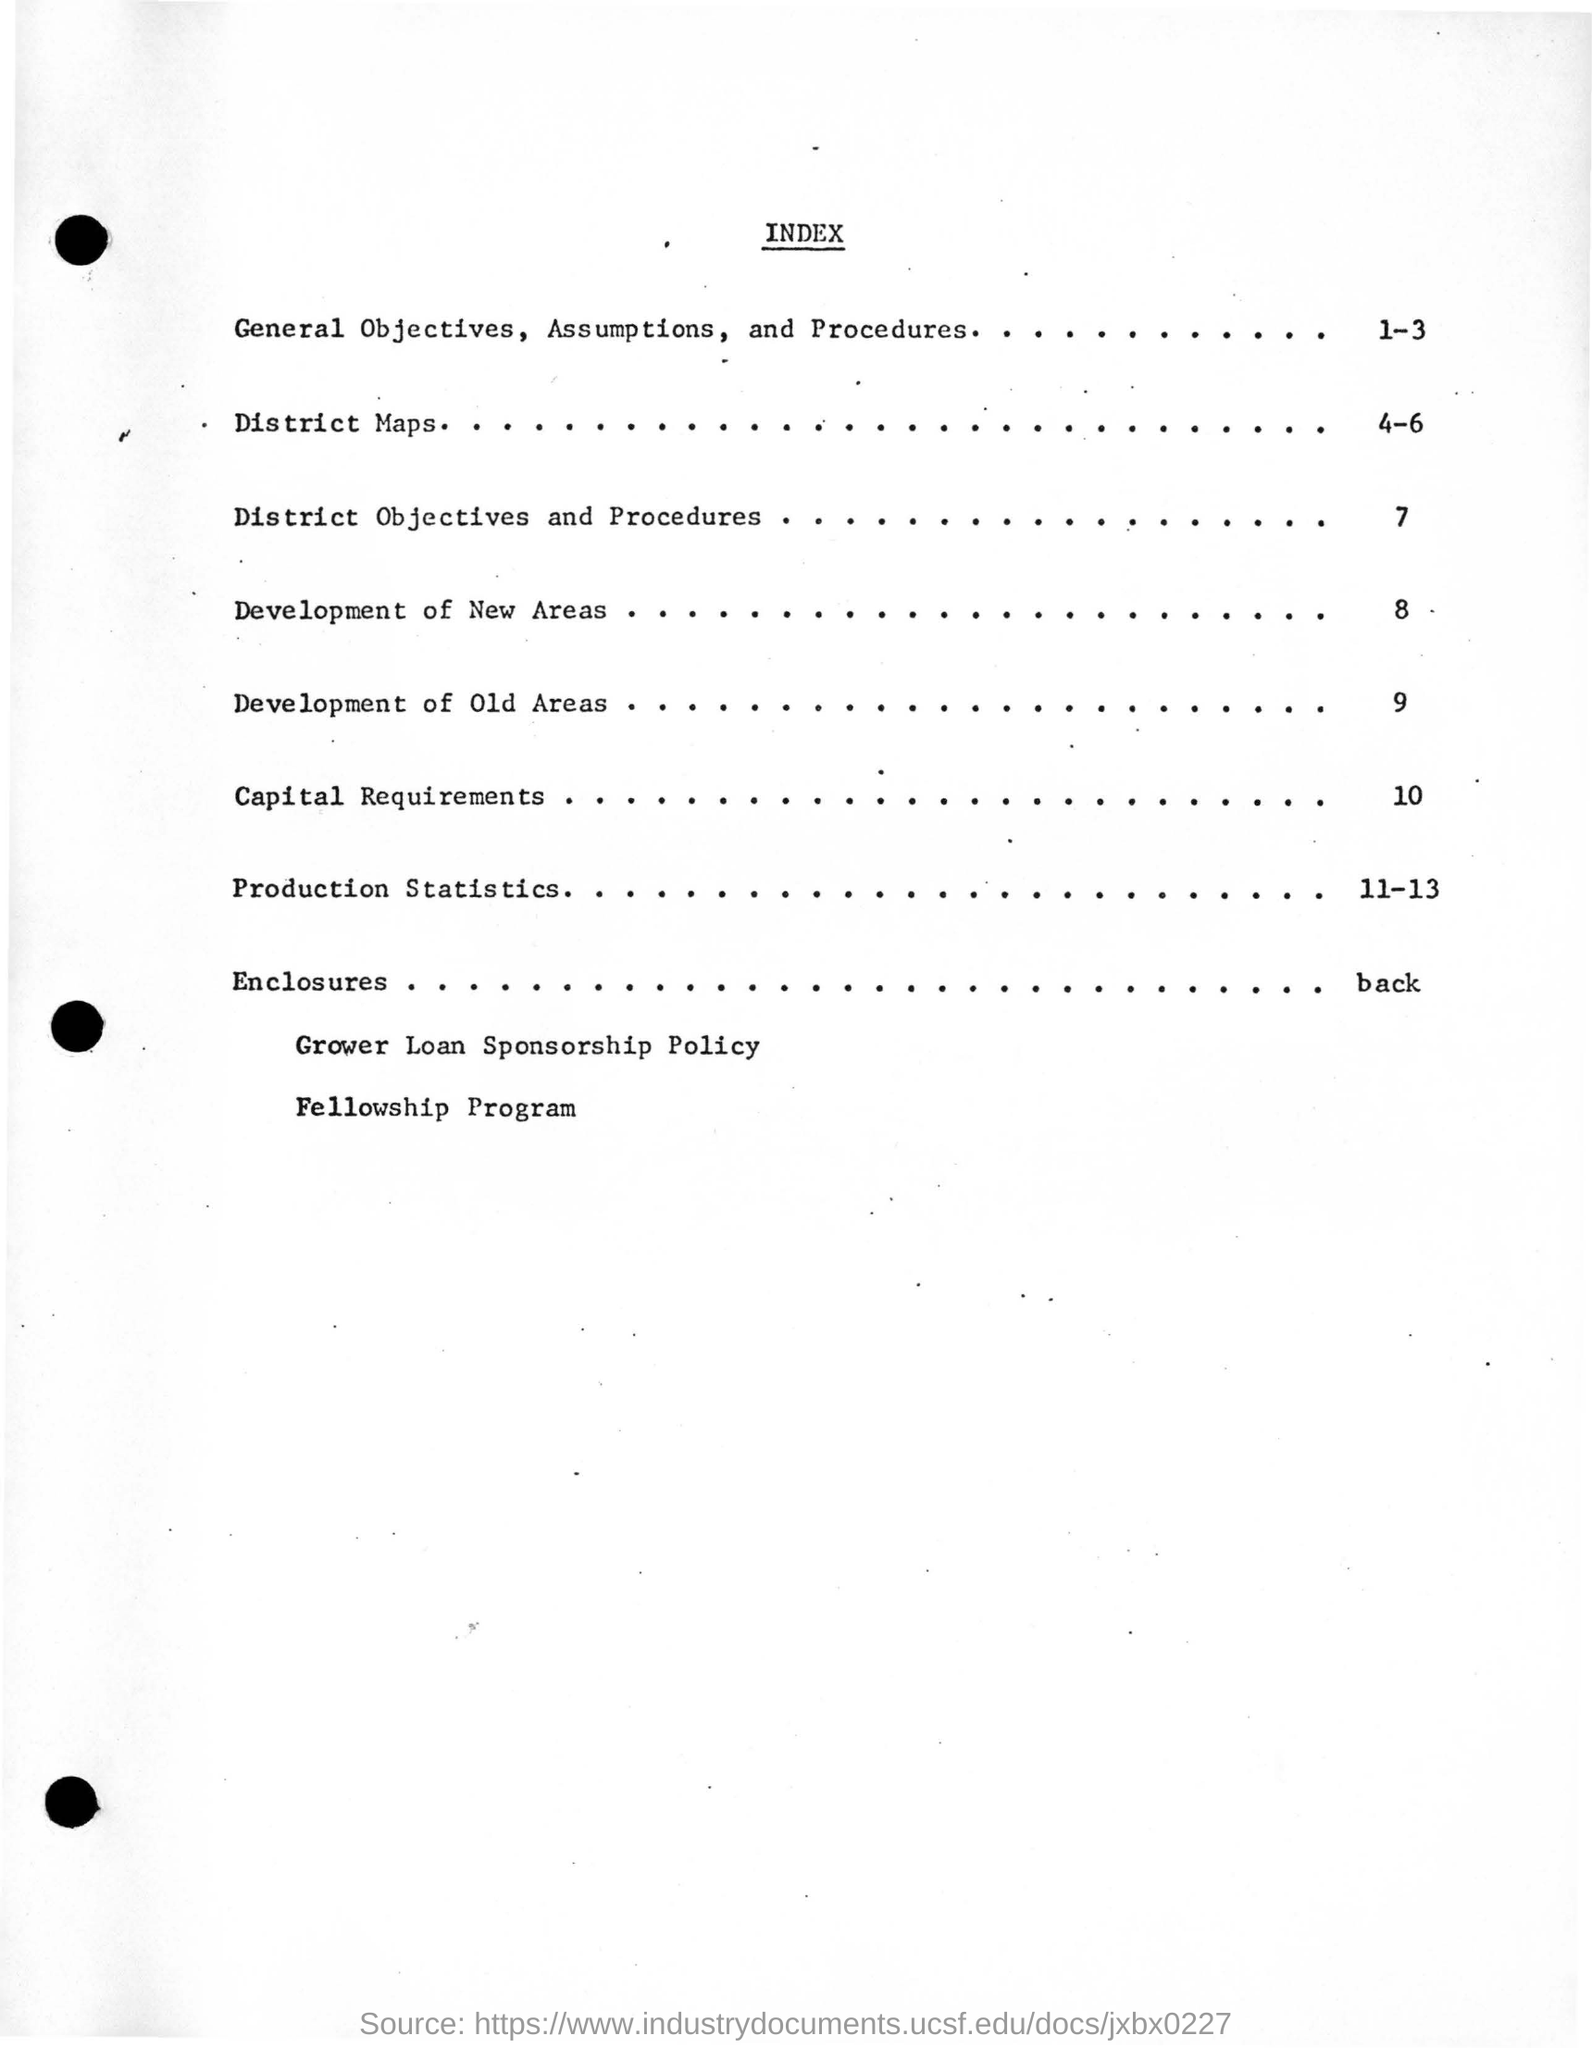What is the heading of the document?
Offer a very short reply. Index. What is on the page number 7?
Your answer should be compact. District Objectives and Procedures. What is the page number of District Maps?
Ensure brevity in your answer.  4-6. What is the last sentence of this document?
Give a very brief answer. Fellowship Program. 